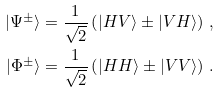<formula> <loc_0><loc_0><loc_500><loc_500>| \Psi ^ { \pm } \rangle & = \frac { 1 } { \sqrt { 2 } } \left ( | H V \rangle \pm | V H \rangle \right ) \, , \\ | \Phi ^ { \pm } \rangle & = \frac { 1 } { \sqrt { 2 } } \left ( | H H \rangle \pm | V V \rangle \right ) \, .</formula> 